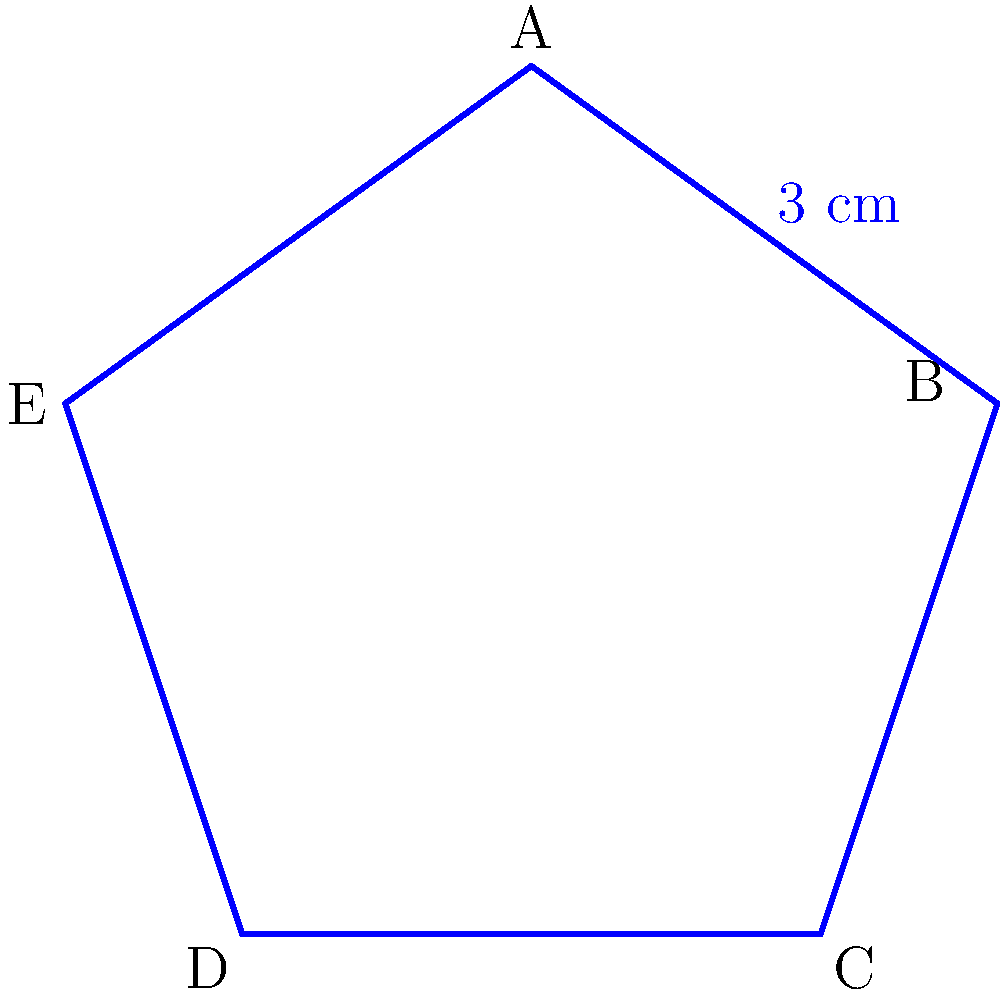For the upcoming International Bollywood Film Festival, you're designing a star-shaped award plaque. The plaque is a regular five-pointed star, where each side measures 3 cm. What is the perimeter of this award plaque? To find the perimeter of the star-shaped award plaque, we need to follow these steps:

1) First, we need to understand what a regular five-pointed star looks like. It has five equal sides and five equal angles.

2) We are given that each side of the star measures 3 cm.

3) To calculate the perimeter, we need to add up the lengths of all sides.

4) Since there are 5 sides, and each side is 3 cm long, we can calculate the perimeter as follows:

   Perimeter $= 5 \times 3$ cm

5) Performing the multiplication:

   Perimeter $= 15$ cm

Therefore, the perimeter of the star-shaped award plaque is 15 cm.
Answer: 15 cm 